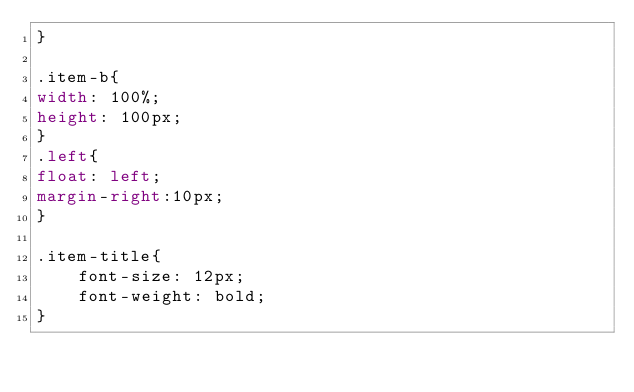Convert code to text. <code><loc_0><loc_0><loc_500><loc_500><_CSS_>}

.item-b{
width: 100%;
height: 100px;
}
.left{
float: left;
margin-right:10px; 
}

.item-title{
    font-size: 12px;
    font-weight: bold;
}</code> 